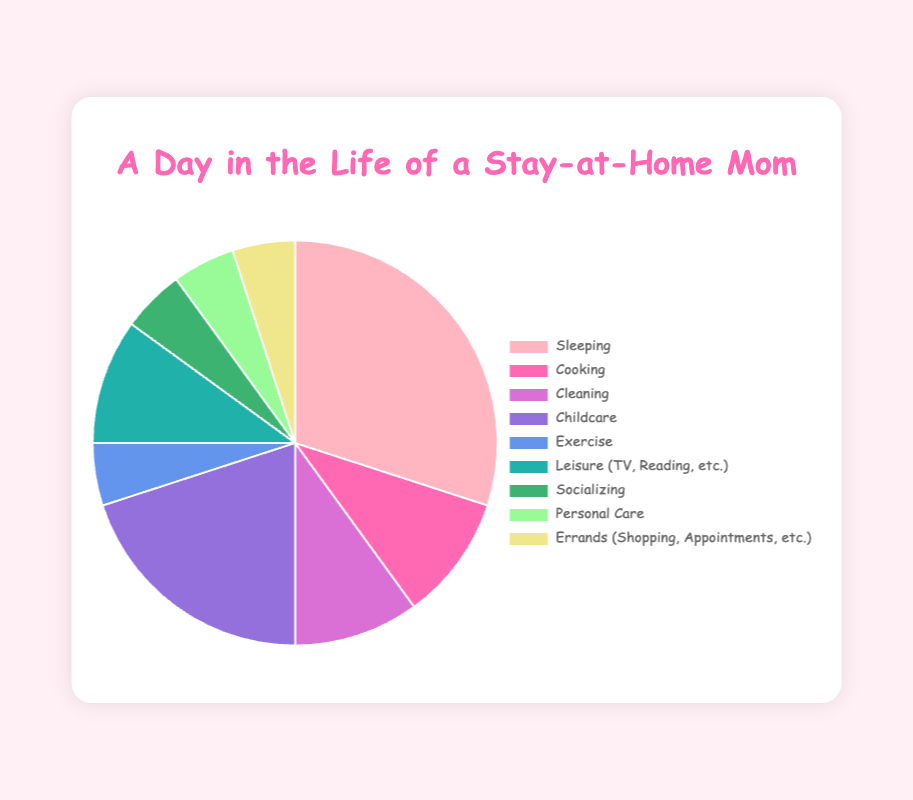What is the largest time allocation for a single activity? The pie chart indicates the percentage of time spent on various activities throughout the day. By visually inspecting the chart, we can see that "Sleeping" has the largest slice representing 30% of the time.
Answer: Sleeping What is the combined percentage of time spent on Cooking and Cleaning? To find the combined percentage, we add the time spent on Cooking (10%) and Cleaning (10%). The sum is 10% + 10% = 20%.
Answer: 20% How much more time is spent on Childcare compared to Exercise? By looking at the pie chart, we see that Childcare has a 20% allocation and Exercise has a 5% allocation. The difference is 20% - 5% = 15%.
Answer: 15% Are there any activities that take up the same amount of time? If so, which ones? By inspecting the slices of the pie chart, we can identify that Cooking, Cleaning, and Leisure each take up 10% of the time. Socializing, Personal Care, and Errands each take up 5% of the time.
Answer: Cooking, Cleaning, and Leisure; Socializing, Personal Care, and Errands Which activities combined together constitute a third of the day? We need to find a combination of activities whose sum is around 33.33%. By examining the chart, we see that Childcare (20%) and any activity that has 10%—Cooking, Cleaning, or Leisure—each add up to 30%. Adding Socializing or any other 5% activity will sum up to 35%, which is close. So, Childcare (20%) + Cooking (10%) + Socializing (5%) = 35%. Although it's not exactly a third, it's close considering the given set of numbers.
Answer: Childcare, Cooking, and Socializing What is the percentage of time spent on activities related to personal well-being (Sleeping, Exercise, Personal Care)? The activities related to personal well-being are Sleeping (30%), Exercise (5%), and Personal Care (5%). Adding these percentages together gives 30% + 5% + 5% = 40%.
Answer: 40% If you combine Childcare, Exercise, and Socializing, how does this combined time compare to time spent Sleeping? Childcare takes 20%, Exercise takes 5%, and Socializing takes 5%. Combined, they account for 20% + 5% + 5% = 30%. This is equal to the time spent Sleeping, which is also 30%.
Answer: Equal Which activity has the smallest allocation and how much is it? In the pie chart, the smallest allocations are to Exercise, Socializing, Personal Care, and Errands, each taking up 5% of the time.
Answer: Exercise, Socializing, Personal Care, and Errands; 5% How much more time is spent on Caring for Children than on Errands? Childcare is allocated 20% of the time, while Errands have 5%. The difference is 20% - 5% = 15%.
Answer: 15% 